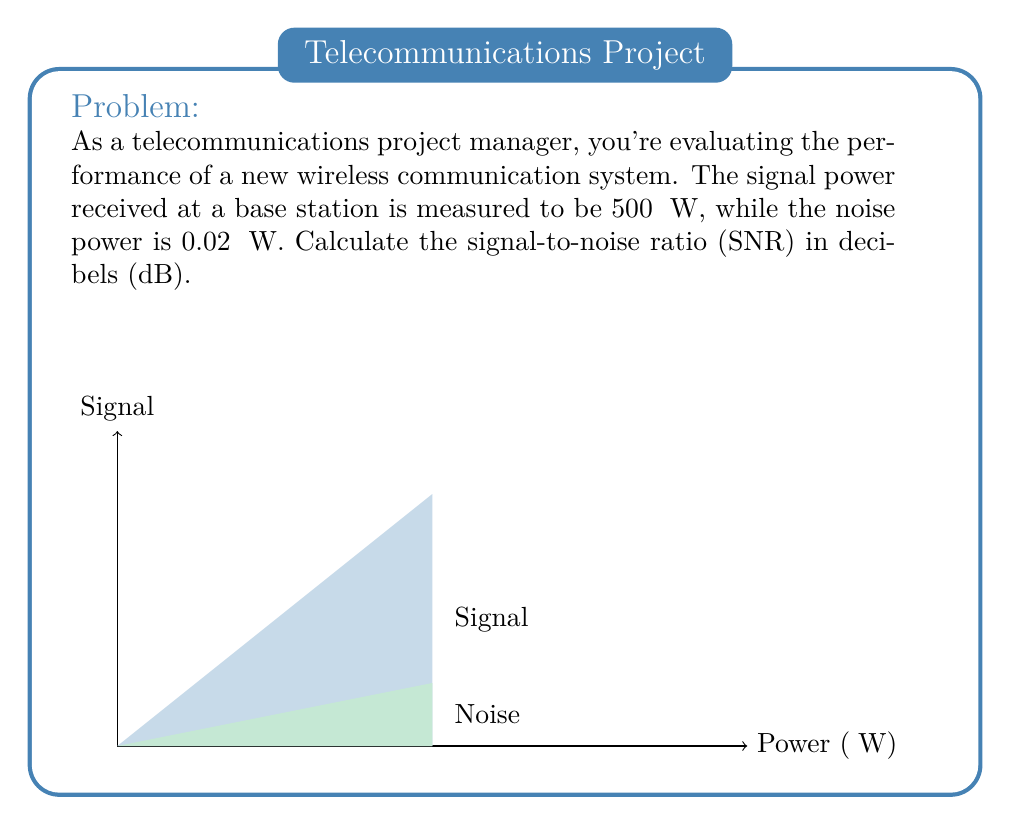Show me your answer to this math problem. To calculate the signal-to-noise ratio (SNR) in decibels, we'll follow these steps:

1) The formula for SNR in decibels is:

   $$ \text{SNR}_{\text{dB}} = 10 \log_{10}\left(\frac{P_{\text{signal}}}{P_{\text{noise}}}\right) $$

2) We're given:
   $P_{\text{signal}} = 500 \text{ μW}$
   $P_{\text{noise}} = 0.02 \text{ μW}$

3) Let's substitute these values into the formula:

   $$ \text{SNR}_{\text{dB}} = 10 \log_{10}\left(\frac{500}{0.02}\right) $$

4) Simplify the fraction inside the logarithm:

   $$ \text{SNR}_{\text{dB}} = 10 \log_{10}(25000) $$

5) Use a calculator or logarithm table to evaluate $\log_{10}(25000)$:

   $$ \log_{10}(25000) \approx 4.3979 $$

6) Multiply this result by 10:

   $$ \text{SNR}_{\text{dB}} = 10 \times 4.3979 \approx 43.979 $$

7) Round to two decimal places for the final answer.
Answer: $43.98 \text{ dB}$ 